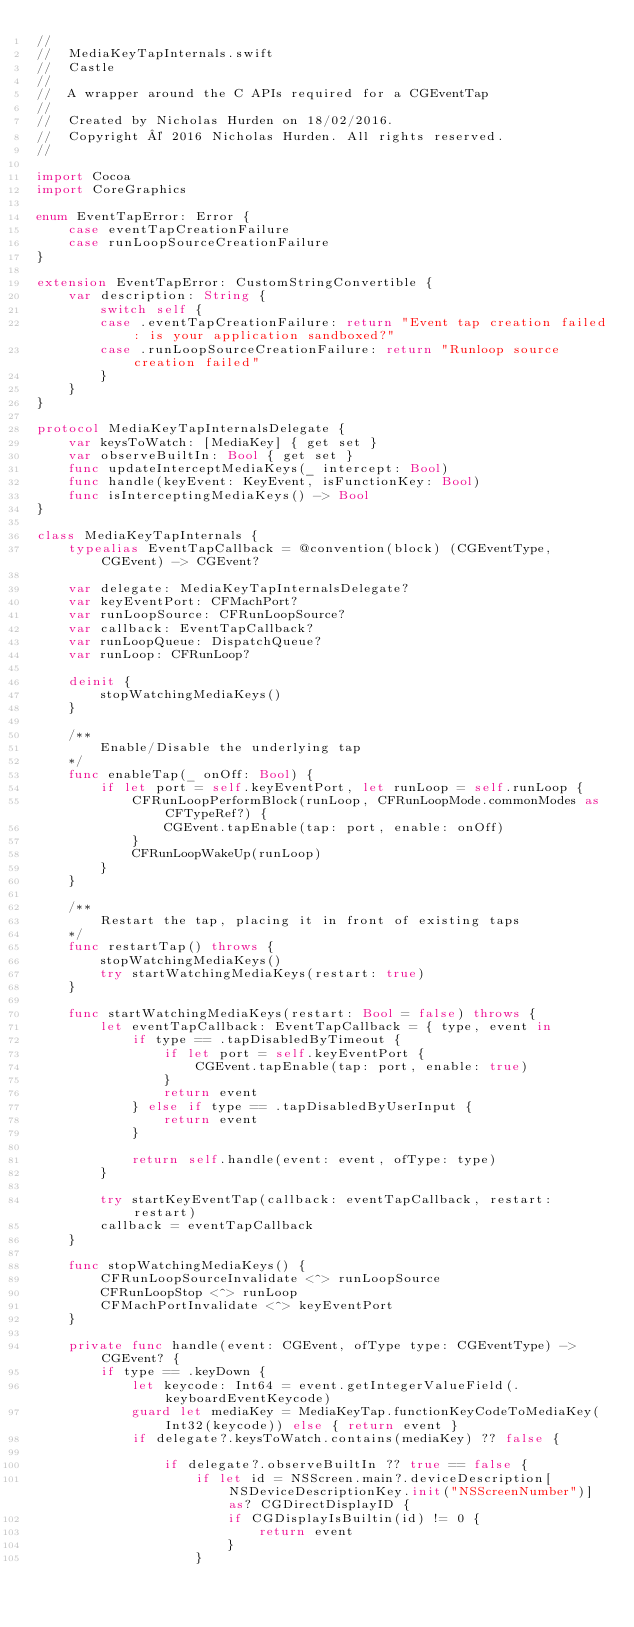<code> <loc_0><loc_0><loc_500><loc_500><_Swift_>//
//  MediaKeyTapInternals.swift
//  Castle
//
//  A wrapper around the C APIs required for a CGEventTap
//
//  Created by Nicholas Hurden on 18/02/2016.
//  Copyright © 2016 Nicholas Hurden. All rights reserved.
//

import Cocoa
import CoreGraphics

enum EventTapError: Error {
    case eventTapCreationFailure
    case runLoopSourceCreationFailure
}

extension EventTapError: CustomStringConvertible {
    var description: String {
        switch self {
        case .eventTapCreationFailure: return "Event tap creation failed: is your application sandboxed?"
        case .runLoopSourceCreationFailure: return "Runloop source creation failed"
        }
    }
}

protocol MediaKeyTapInternalsDelegate {
	var keysToWatch: [MediaKey] { get set }
	var observeBuiltIn: Bool { get set }
    func updateInterceptMediaKeys(_ intercept: Bool)
	func handle(keyEvent: KeyEvent, isFunctionKey: Bool)
    func isInterceptingMediaKeys() -> Bool
}

class MediaKeyTapInternals {
    typealias EventTapCallback = @convention(block) (CGEventType, CGEvent) -> CGEvent?

    var delegate: MediaKeyTapInternalsDelegate?
    var keyEventPort: CFMachPort?
    var runLoopSource: CFRunLoopSource?
    var callback: EventTapCallback?
    var runLoopQueue: DispatchQueue?
    var runLoop: CFRunLoop?

    deinit {
        stopWatchingMediaKeys()
    }

    /**
        Enable/Disable the underlying tap
    */
    func enableTap(_ onOff: Bool) {
        if let port = self.keyEventPort, let runLoop = self.runLoop {
            CFRunLoopPerformBlock(runLoop, CFRunLoopMode.commonModes as CFTypeRef?) {
                CGEvent.tapEnable(tap: port, enable: onOff)
            }
            CFRunLoopWakeUp(runLoop)
        }
    }

    /**
        Restart the tap, placing it in front of existing taps
    */
    func restartTap() throws {
        stopWatchingMediaKeys()
        try startWatchingMediaKeys(restart: true)
    }

    func startWatchingMediaKeys(restart: Bool = false) throws {
        let eventTapCallback: EventTapCallback = { type, event in
            if type == .tapDisabledByTimeout {
                if let port = self.keyEventPort {
                    CGEvent.tapEnable(tap: port, enable: true)
                }
                return event
            } else if type == .tapDisabledByUserInput {
                return event
            }

            return self.handle(event: event, ofType: type)
        }

        try startKeyEventTap(callback: eventTapCallback, restart: restart)
        callback = eventTapCallback
    }

    func stopWatchingMediaKeys() {
        CFRunLoopSourceInvalidate <^> runLoopSource
        CFRunLoopStop <^> runLoop
        CFMachPortInvalidate <^> keyEventPort
    }

    private func handle(event: CGEvent, ofType type: CGEventType) -> CGEvent? {
		if type == .keyDown {
			let keycode: Int64 = event.getIntegerValueField(.keyboardEventKeycode)
			guard let mediaKey = MediaKeyTap.functionKeyCodeToMediaKey(Int32(keycode)) else { return event }
			if delegate?.keysToWatch.contains(mediaKey) ?? false {

				if delegate?.observeBuiltIn ?? true == false {
					if let id = NSScreen.main?.deviceDescription[NSDeviceDescriptionKey.init("NSScreenNumber")] as? CGDirectDisplayID {
						if CGDisplayIsBuiltin(id) != 0 {
							return event
						}
					}</code> 